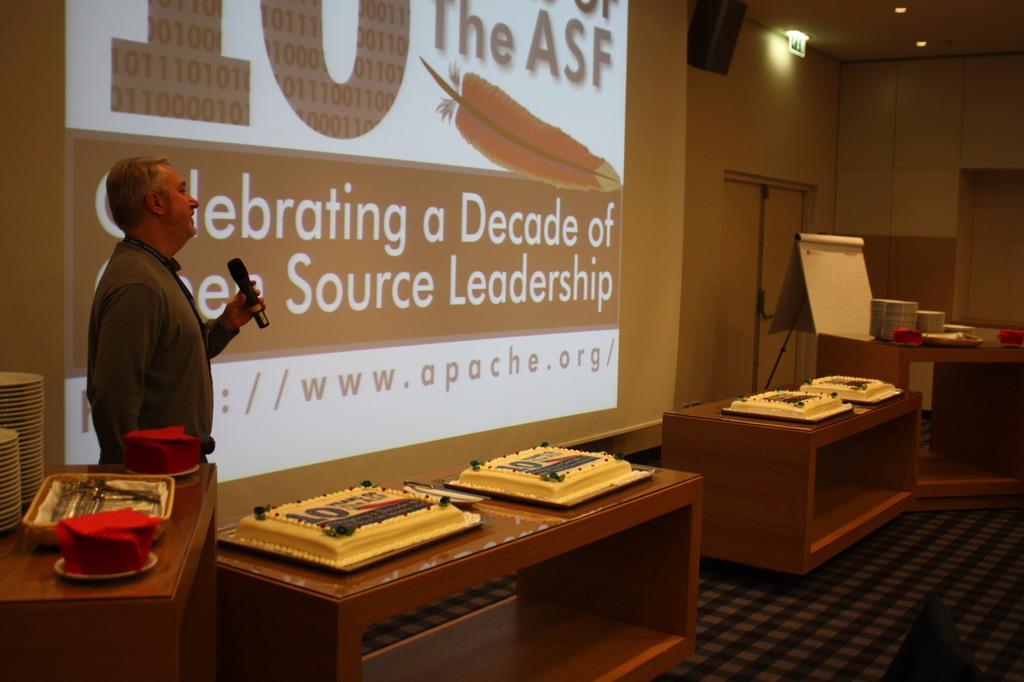Please provide a concise description of this image. In this image we can see a man is standing. He is wearing shirt and holding mic in his hand. In front of him tables are there. On tables cakes are present. Behind him big screen is there. Right side of the image one table is there. On table plate are arranged. Behind the table stand and board is present. And one door is there. Left bottom of the image one more table is there. On tablespoon, plates and red color things are present. 